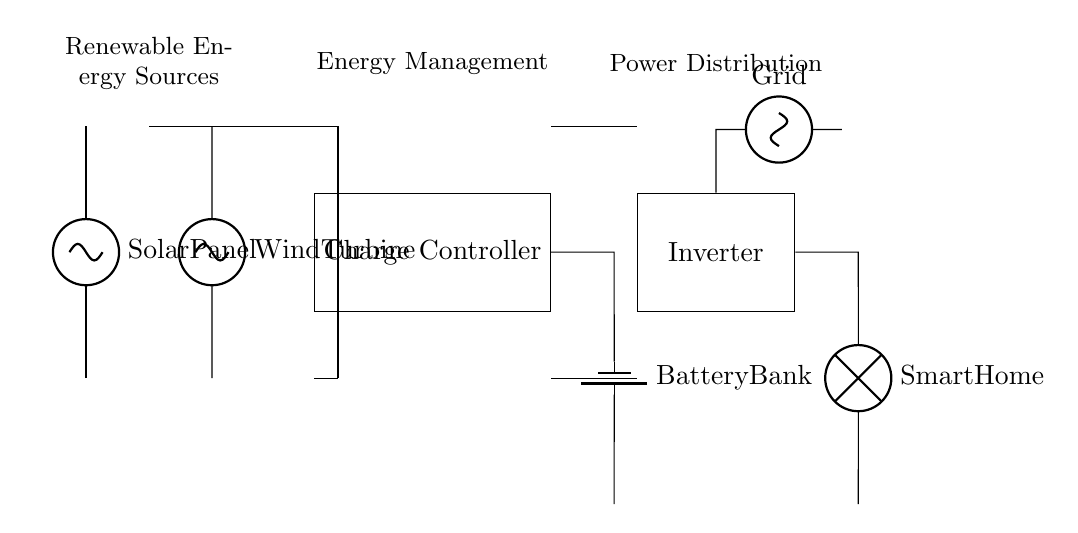What renewable energy sources are represented in the circuit? The circuit diagram shows a solar panel and a wind turbine as renewable energy sources. These components are distinctly labeled in the diagram.
Answer: Solar Panel, Wind Turbine What is the purpose of the charge controller in this circuit? The charge controller regulates the voltage and current coming from the renewable energy sources to charge the battery safely and efficiently. It's positioned between the energy sources and the battery bank in the diagram.
Answer: Regulate charging Which component is responsible for converting DC to AC? The inverter converts direct current (DC) from the battery bank to alternating current (AC) for household use. It's clearly labeled and positioned before the smart home load in the circuit.
Answer: Inverter How many main components are there in the energy management section of the circuit? The energy management section primarily consists of the charge controller and the battery bank. Both are part of the system managing the energy flow from sources to storage. There are two main components.
Answer: Two What does the grid connection provide in this circuit? The grid connection offers an additional power source, allowing the smart home to draw electricity from the grid when necessary, ensuring reliability. This connection is shown at the top of the inverter.
Answer: Additional power source How is the smart home load powered in this configuration? The smart home load is powered by the inverter, which converts the stored energy from the battery bank into usable AC power when needed. This connection is depicted directly connected to the inverter in the diagram.
Answer: Through an inverter 